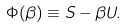<formula> <loc_0><loc_0><loc_500><loc_500>\Phi ( \beta ) \equiv S - \beta U .</formula> 